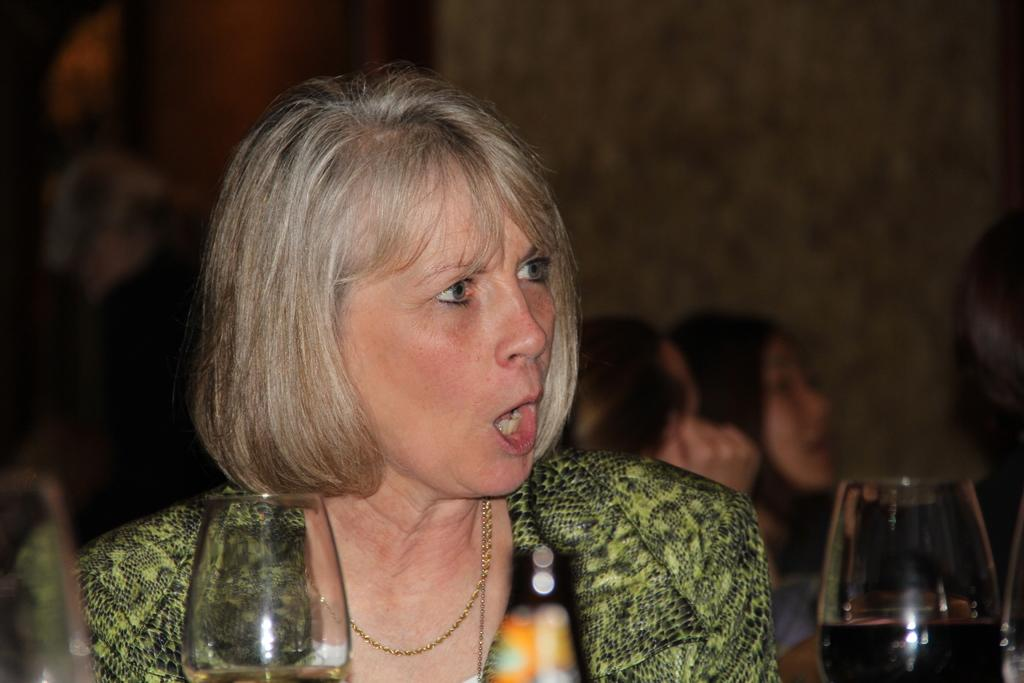Who or what can be seen in the image? There are people in the image. What objects are present in the image? There are glasses and a bottle in the image. Can you describe the background of the image? The background of the image is blurred. Where is the sink located in the image? There is no sink present in the image. What type of leaf can be seen falling in the image? There are no leaves present in the image. 